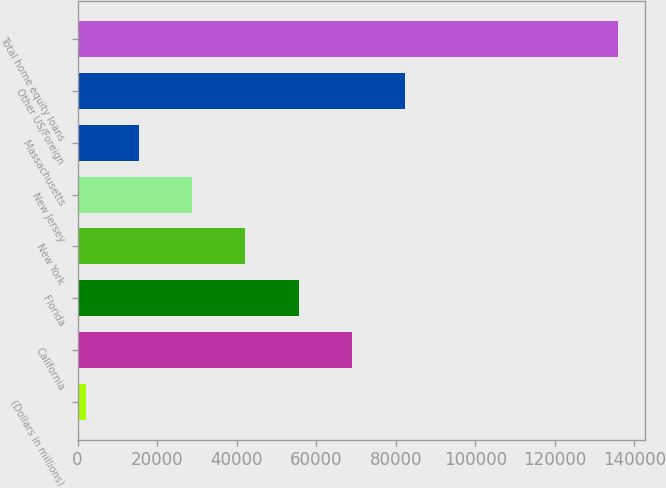Convert chart to OTSL. <chart><loc_0><loc_0><loc_500><loc_500><bar_chart><fcel>(Dollars in millions)<fcel>California<fcel>Florida<fcel>New York<fcel>New Jersey<fcel>Massachusetts<fcel>Other US/Foreign<fcel>Total home equity loans<nl><fcel>2009<fcel>68960.5<fcel>55570.2<fcel>42179.9<fcel>28789.6<fcel>15399.3<fcel>82350.8<fcel>135912<nl></chart> 